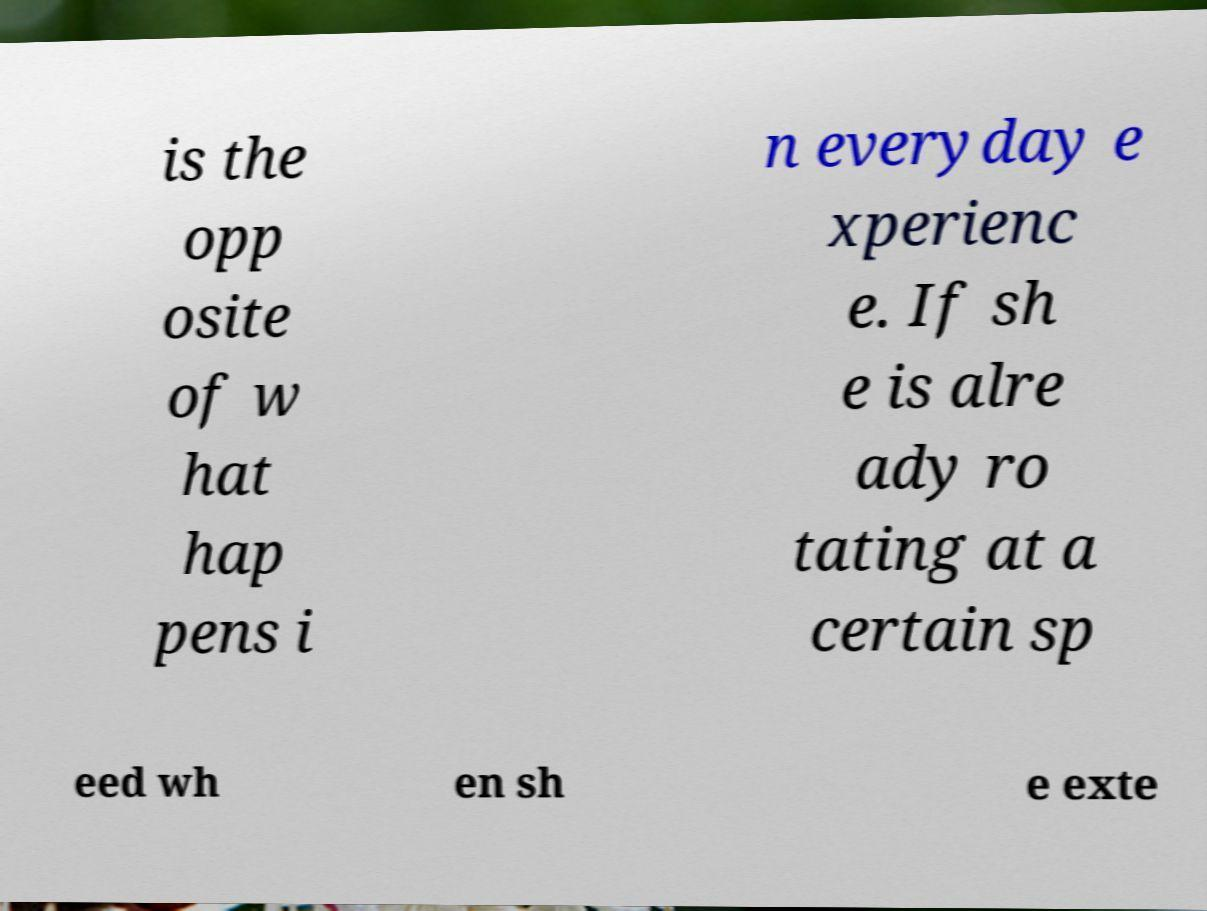Could you extract and type out the text from this image? is the opp osite of w hat hap pens i n everyday e xperienc e. If sh e is alre ady ro tating at a certain sp eed wh en sh e exte 